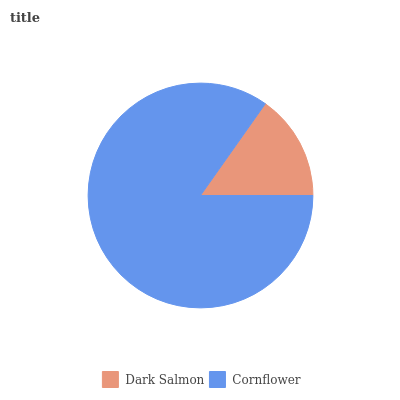Is Dark Salmon the minimum?
Answer yes or no. Yes. Is Cornflower the maximum?
Answer yes or no. Yes. Is Cornflower the minimum?
Answer yes or no. No. Is Cornflower greater than Dark Salmon?
Answer yes or no. Yes. Is Dark Salmon less than Cornflower?
Answer yes or no. Yes. Is Dark Salmon greater than Cornflower?
Answer yes or no. No. Is Cornflower less than Dark Salmon?
Answer yes or no. No. Is Cornflower the high median?
Answer yes or no. Yes. Is Dark Salmon the low median?
Answer yes or no. Yes. Is Dark Salmon the high median?
Answer yes or no. No. Is Cornflower the low median?
Answer yes or no. No. 